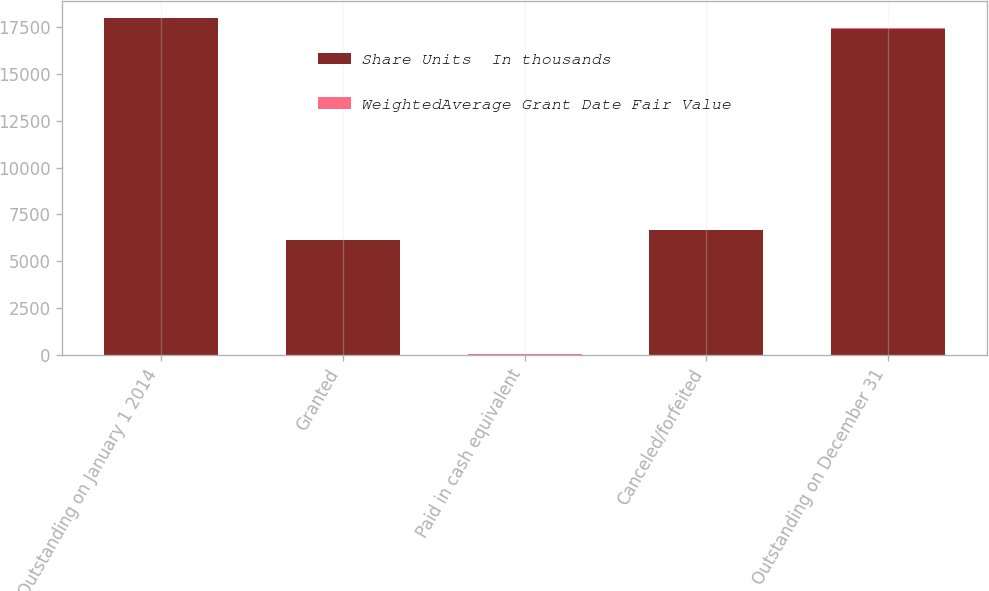Convert chart. <chart><loc_0><loc_0><loc_500><loc_500><stacked_bar_chart><ecel><fcel>Outstanding on January 1 2014<fcel>Granted<fcel>Paid in cash equivalent<fcel>Canceled/forfeited<fcel>Outstanding on December 31<nl><fcel>Share Units  In thousands<fcel>17974<fcel>6117<fcel>5<fcel>6660<fcel>17426<nl><fcel>WeightedAverage Grant Date Fair Value<fcel>30.41<fcel>32.33<fcel>30.59<fcel>29.11<fcel>31.59<nl></chart> 